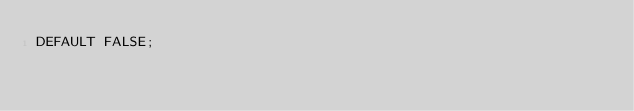<code> <loc_0><loc_0><loc_500><loc_500><_SQL_>DEFAULT FALSE;
</code> 